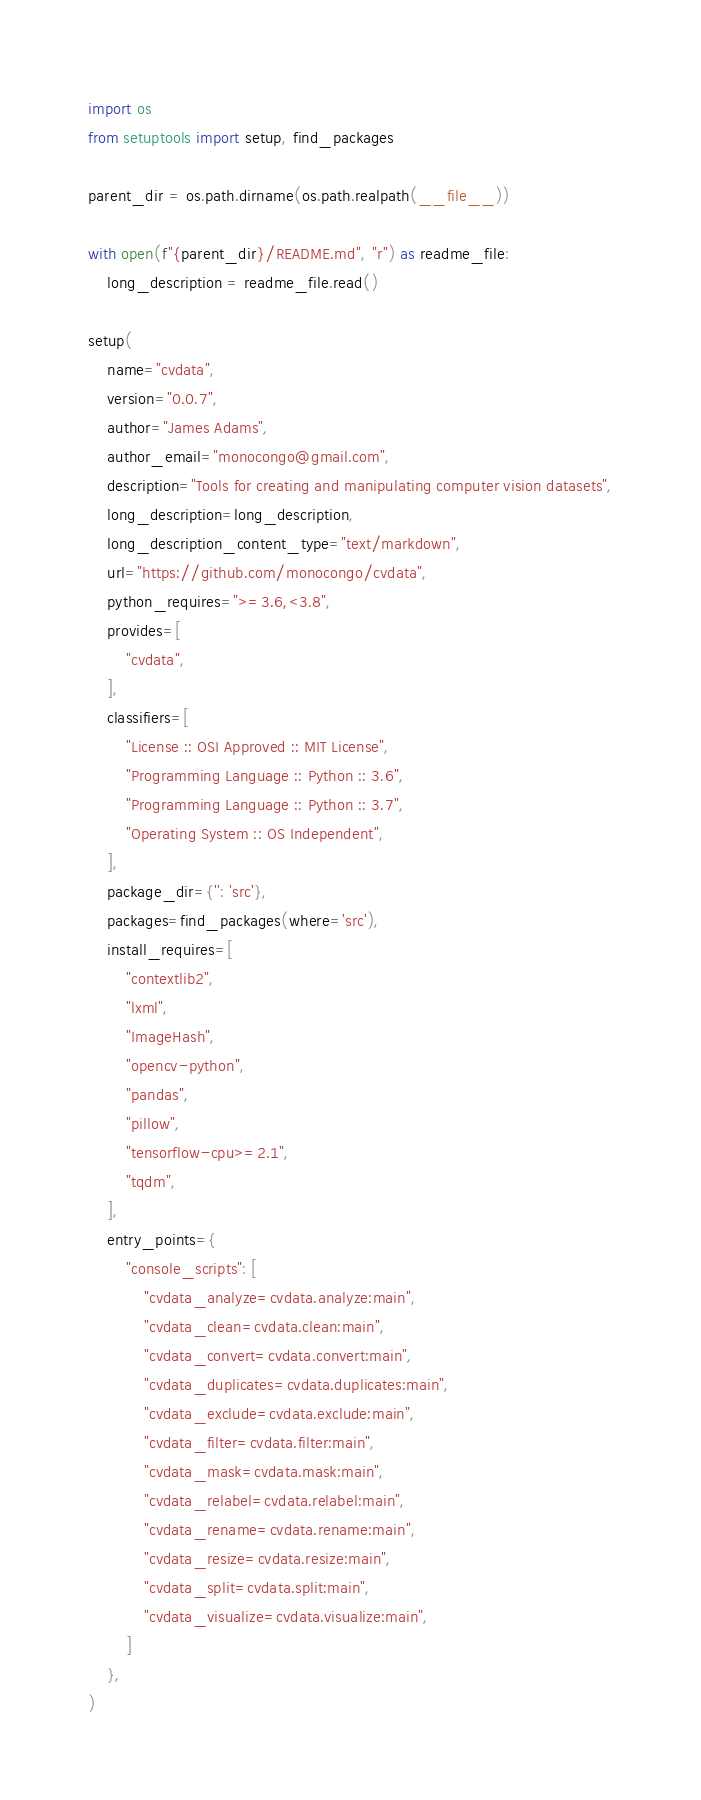<code> <loc_0><loc_0><loc_500><loc_500><_Python_>import os
from setuptools import setup, find_packages

parent_dir = os.path.dirname(os.path.realpath(__file__))

with open(f"{parent_dir}/README.md", "r") as readme_file:
    long_description = readme_file.read()

setup(
    name="cvdata",
    version="0.0.7",
    author="James Adams",
    author_email="monocongo@gmail.com",
    description="Tools for creating and manipulating computer vision datasets",
    long_description=long_description,
    long_description_content_type="text/markdown",
    url="https://github.com/monocongo/cvdata",
    python_requires=">=3.6,<3.8",
    provides=[
        "cvdata",
    ],
    classifiers=[
        "License :: OSI Approved :: MIT License",
        "Programming Language :: Python :: 3.6",
        "Programming Language :: Python :: 3.7",
        "Operating System :: OS Independent",
    ],
    package_dir={'': 'src'},
    packages=find_packages(where='src'),
    install_requires=[
        "contextlib2",
        "lxml",
        "ImageHash",
        "opencv-python",
        "pandas",
        "pillow",
        "tensorflow-cpu>=2.1",
        "tqdm",
    ],
    entry_points={
        "console_scripts": [
            "cvdata_analyze=cvdata.analyze:main",
            "cvdata_clean=cvdata.clean:main",
            "cvdata_convert=cvdata.convert:main",
            "cvdata_duplicates=cvdata.duplicates:main",
            "cvdata_exclude=cvdata.exclude:main",
            "cvdata_filter=cvdata.filter:main",
            "cvdata_mask=cvdata.mask:main",
            "cvdata_relabel=cvdata.relabel:main",
            "cvdata_rename=cvdata.rename:main",
            "cvdata_resize=cvdata.resize:main",
            "cvdata_split=cvdata.split:main",
            "cvdata_visualize=cvdata.visualize:main",
        ]
    },
)
</code> 